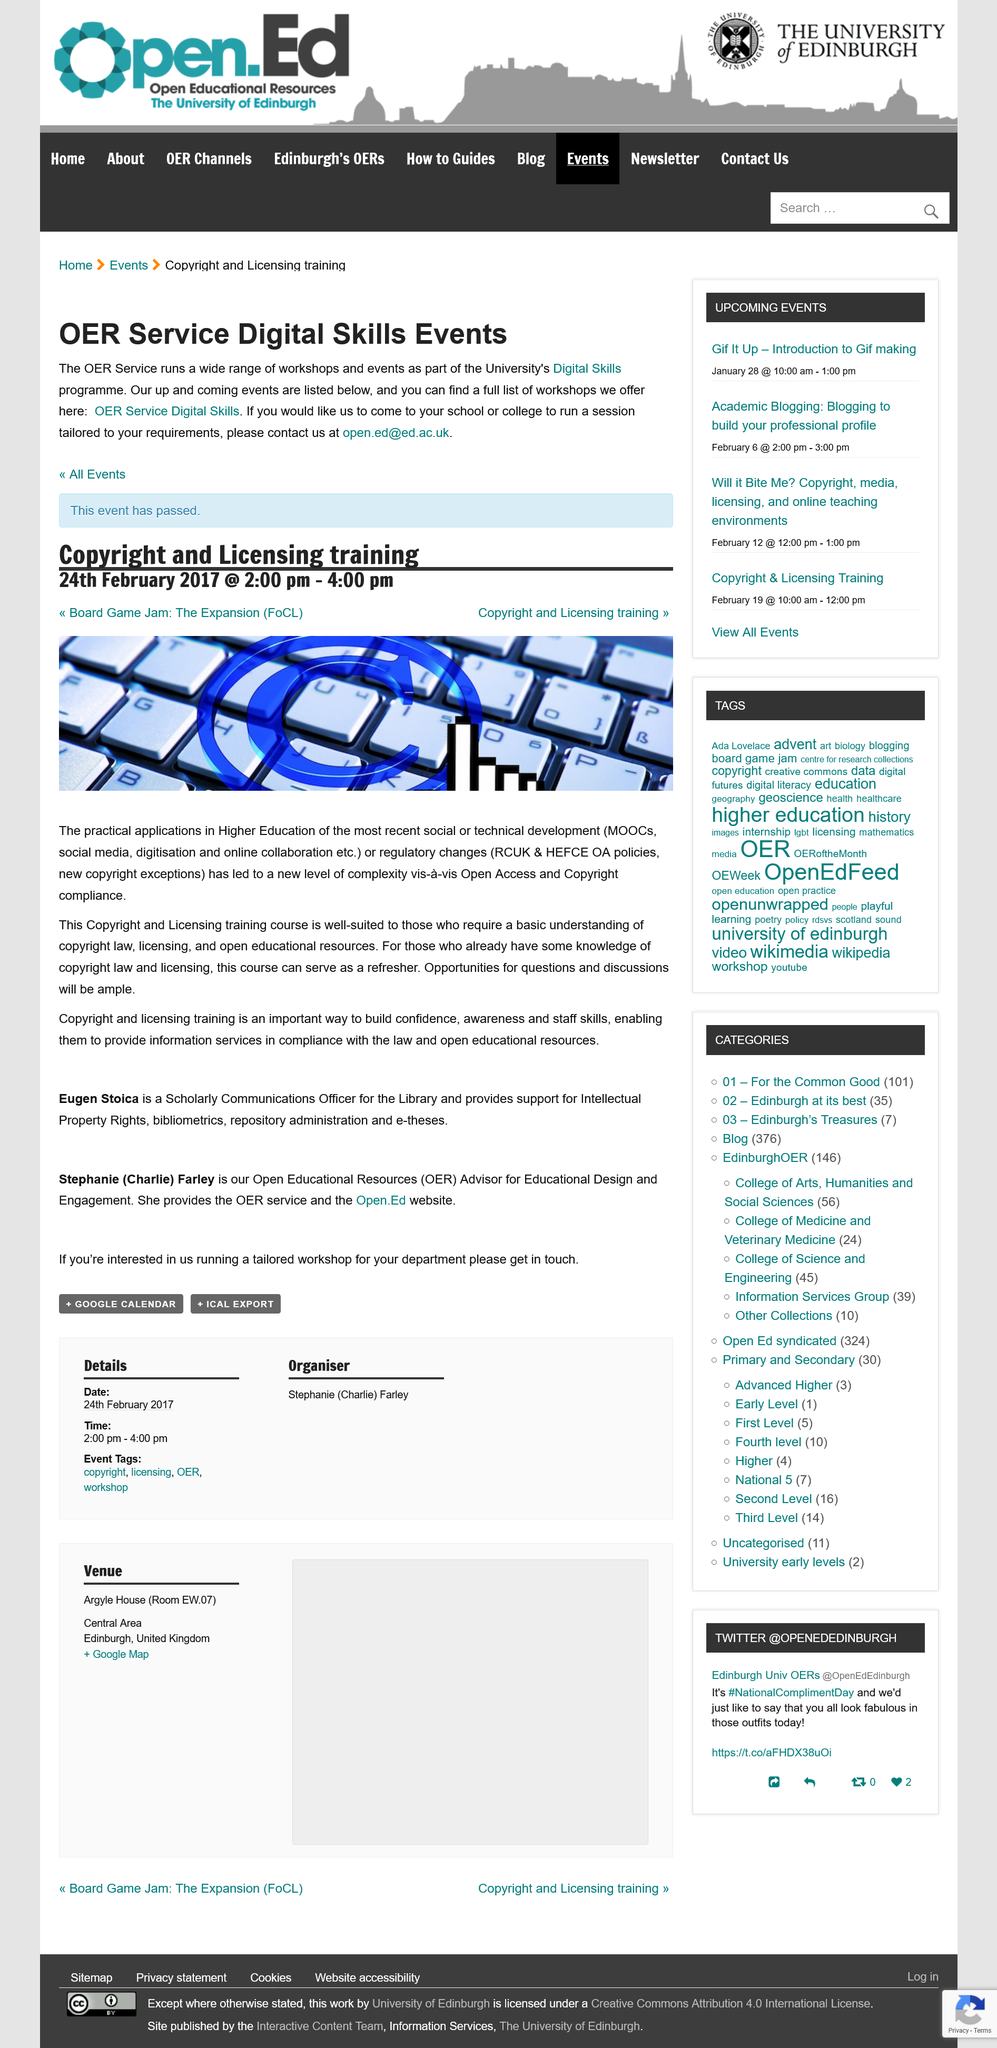Highlight a few significant elements in this photo. The Copyright and Licensing training was held on February 24th, 2017. The event's name is Copyright and Licensing training. The event was scheduled to run until 4:00pm. 